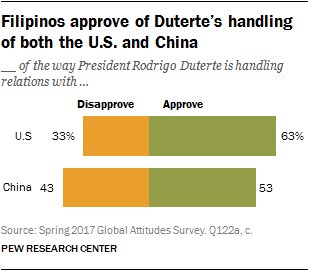List a handful of essential elements in this visual. The ratio of those who disapprove of the job the President is doing to those who approve of it in the United States is 0.5238095238095238... The largest orange bar has a value of 43. 